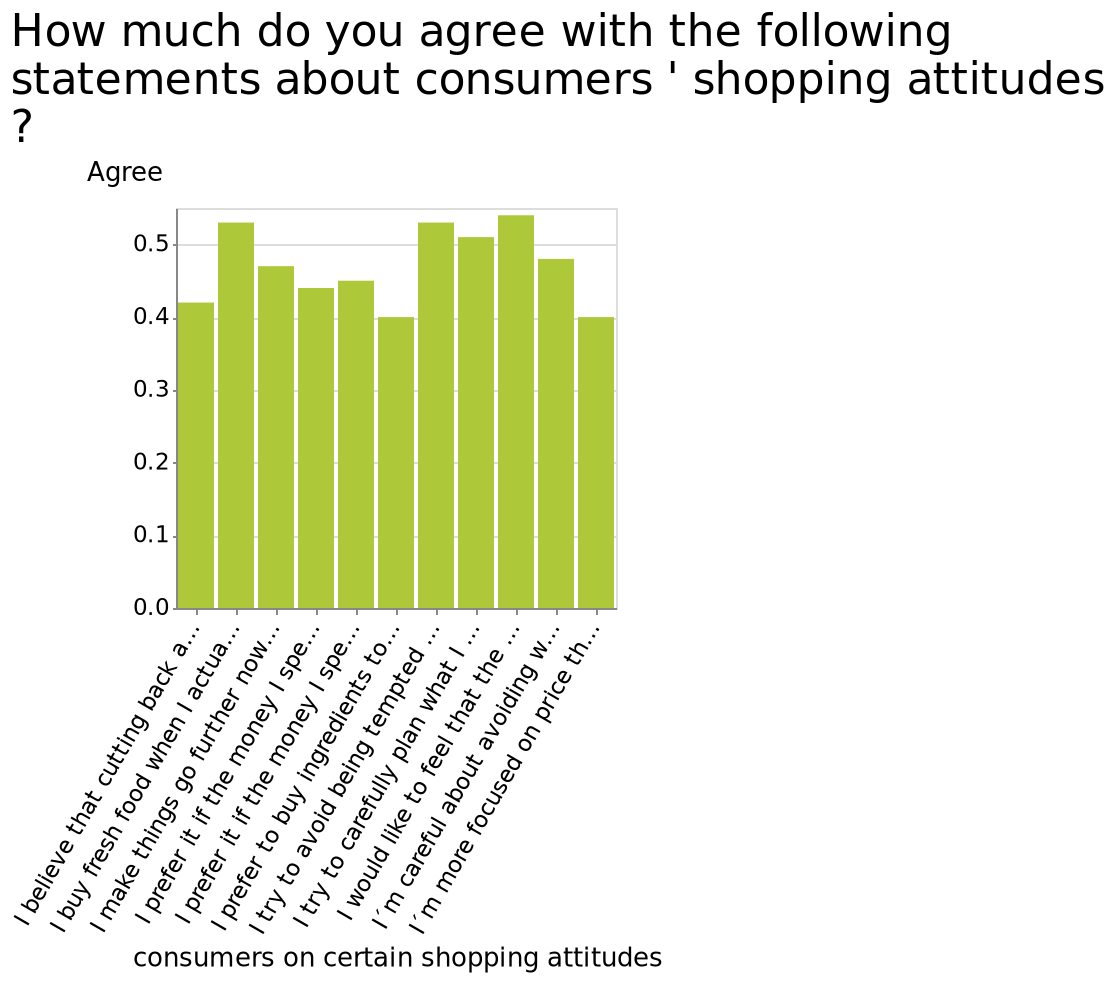<image>
Describe the following image in detail Here a bar graph is labeled How much do you agree with the following statements about consumers ' shopping attitudes ?. The y-axis plots Agree while the x-axis shows consumers on certain shopping attitudes. What does the x-axis represent on the bar graph?  The x-axis represents different shopping attitudes of consumers. How are the shopping attitudes of consumers represented on the bar graph?  The shopping attitudes of consumers are represented along the x-axis of the bar graph. Is there a consumer habit that stands out as being more popular than others? No, there is no particular habit from consumers that stands out as being more popular than the rest. What is the main focus of this bar graph?  The main focus of this bar graph is to measure the level of agreement with various statements about consumers' shopping attitudes. 